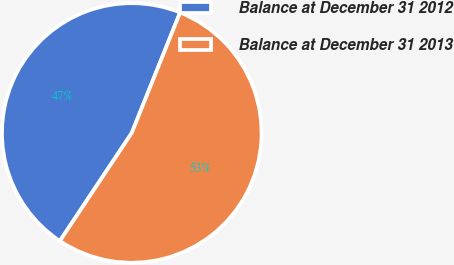Convert chart to OTSL. <chart><loc_0><loc_0><loc_500><loc_500><pie_chart><fcel>Balance at December 31 2012<fcel>Balance at December 31 2013<nl><fcel>46.73%<fcel>53.27%<nl></chart> 